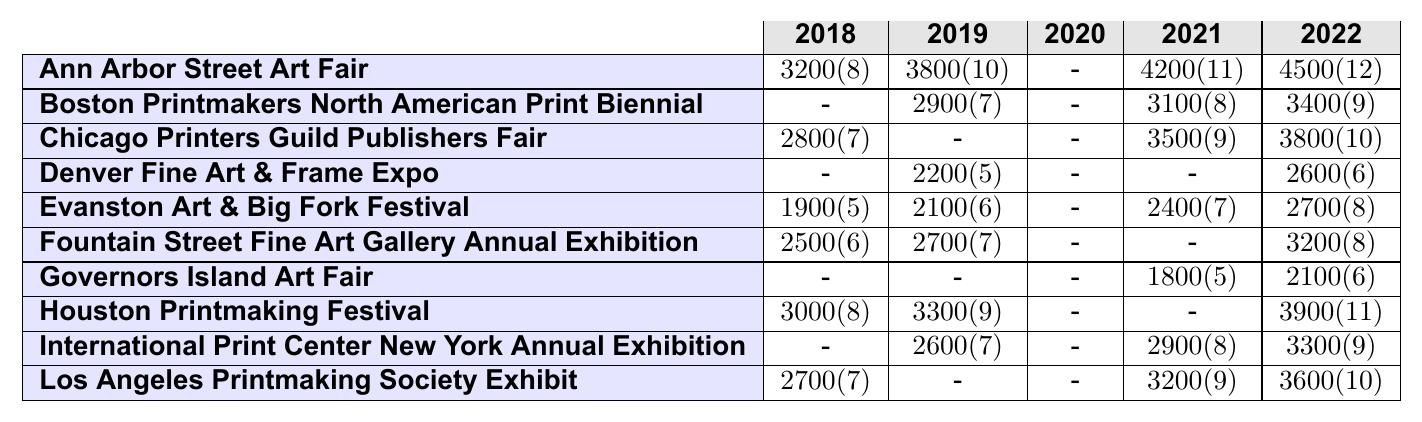What was the highest sales amount achieved in 2022? In 2022, the highest sales amount is found in the "Los Angeles Printmaking Society Exhibit," which is $3600.
Answer: $3600 Which event had the most artworks sold in 2019? In 2019, "Houston Printmaking Festival" and "Evanston Art & Big Fork Festival" each had the highest number of artworks sold at 9.
Answer: 9 Did you participate in the "Governors Island Art Fair" in 2020? The table shows a participation value of 0 for the "Governors Island Art Fair" in 2020, which means there was no participation.
Answer: No What was the total sales amount across all events in 2021? By adding up all the sales amounts for 2021: $4200 + $3100 + $3500 + $0 + $2400 + $0 + $1800 + $0 + $2900 + $3200 = $18900.
Answer: $18900 How many artworks were sold at the "Fountain Street Fine Art Gallery Annual Exhibition" in 2018 and 2022 combined? The artworks sold in 2018 is 6 and in 2022 is 8. Adding them together gives 6 + 8 = 14.
Answer: 14 In which year did you make sales of over $3000 at the "Chicago Printers Guild Publishers Fair"? Referring to the table, in 2021 and 2022, the sales were $3500 and $3800 respectively; both are over $3000.
Answer: 2021 and 2022 What percentage of the events did you participate in during 2020? You participated in 3 events out of 10 in 2020, so the percentage is (3/10) * 100 = 30%.
Answer: 30% Which event had consistent participation from 2018 to 2022? Looking at the participation data, "Ann Arbor Street Art Fair" shows participation in 2018, 2019, 2021, and 2022 but none in 2020, therefore no event had consistent participation across all five years.
Answer: None How many total artworks did you sell at the "International Print Center New York Annual Exhibition" from 2018 to 2022? The total artworks sold in each year are 0 (2018), 7 (2019), 0 (2020), 8 (2021), and 9 (2022). Adding these gives 0 + 7 + 0 + 8 + 9 = 24.
Answer: 24 What was the trend in sales over the years for the "Evanston Art & Big Fork Festival"? Analyzing the sales: $1900 (2018), $2100 (2019), $2400 (2021), $2700 (2022). This shows a consistent increase except for 2020 (0). The trend is upward.
Answer: Upward trend 